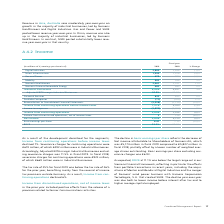According to Siemens Ag's financial document, What was the impact of development described for the segments? As a result of the development described for the segments, Income from continuing operations before income taxes declined 7 %. The document states: "As a result of the development described for the segments, Income from continuing operations before income taxes declined 7 %. Severance charges for c..." Also, What was the tax rate in 2019? Based on the financial document, the answer is 25%. Also, What do the decline in basic earnings per share represent? Based on the financial document, the answer is The decline in basic earnings per share reflects the decrease of Net income attributable to Shareholders of Siemens AG, which was € 5,174 million in fiscal 2019 compared to € 5,807 million in fiscal 2018, partially offset by a lower number of weighted average shares outstanding. Basic earnings per share excluding severance charges was € 6.93.. Also, can you calculate: What was the average of digital industries in 2019 and 2018? To answer this question, I need to perform calculations using the financial data. The calculation is: (2,880 + 2,898) / 2, which equals 2889 (in millions). This is based on the information: "Digital Industries 2,880 2,898 (1) % Digital Industries 2,880 2,898 (1) %..." The key data points involved are: 2,880, 2,898. Also, can you calculate: What is the increase / (decrease) in the Gas and Power from 2018 to 2019? Based on the calculation: 679 - 722, the result is -43 (in millions). This is based on the information: "Gas and Power 679 722 (6) % Gas and Power 679 722 (6) %..." The key data points involved are: 679, 722. Also, can you calculate: What is the increase / (decrease) in ROCE from 2018 to 2019? Based on the calculation: 11.1% - 12.6%, the result is -1.5 (percentage). This is based on the information: "ROCE 11.1 % 12.6 % ROCE 11.1 % 12.6 %..." The key data points involved are: 11.1, 12.6. 